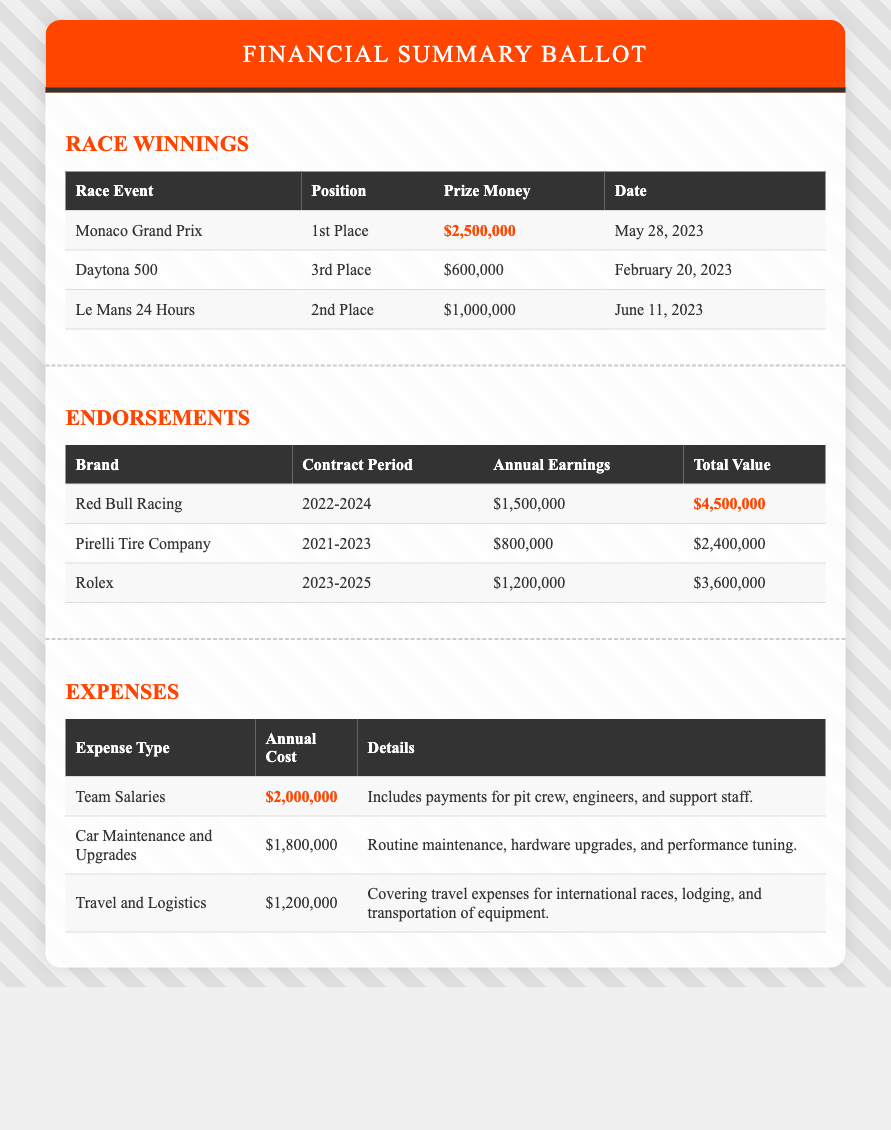What was the prize money for the Monaco Grand Prix? The prize money listed in the document for the Monaco Grand Prix is $2,500,000.
Answer: $2,500,000 How much did you earn in endorsements from Red Bull Racing? The annual earnings from Red Bull Racing are listed as $1,500,000.
Answer: $1,500,000 What was your position in the Le Mans 24 Hours? The document states that the position in the Le Mans 24 Hours was 2nd Place.
Answer: 2nd Place What is the total value of the endorsement with Rolex? The total value of the endorsement with Rolex is listed as $3,600,000.
Answer: $3,600,000 What is the annual cost associated with Team Salaries? The annual cost for Team Salaries is indicated as $2,000,000.
Answer: $2,000,000 Which race event had the highest prize money? The record for the highest prize money among the listed events is attributed to the Monaco Grand Prix.
Answer: Monaco Grand Prix What were the expenses for Car Maintenance and Upgrades? The expenses for Car Maintenance and Upgrades are detailed as $1,800,000.
Answer: $1,800,000 How long is the contract period with Pirelli Tire Company? The document indicates that the contract period with Pirelli Tire Company is from 2021 to 2023.
Answer: 2021-2023 How many races are listed under Race Winnings? There are a total of three races mentioned under Race Winnings.
Answer: Three 